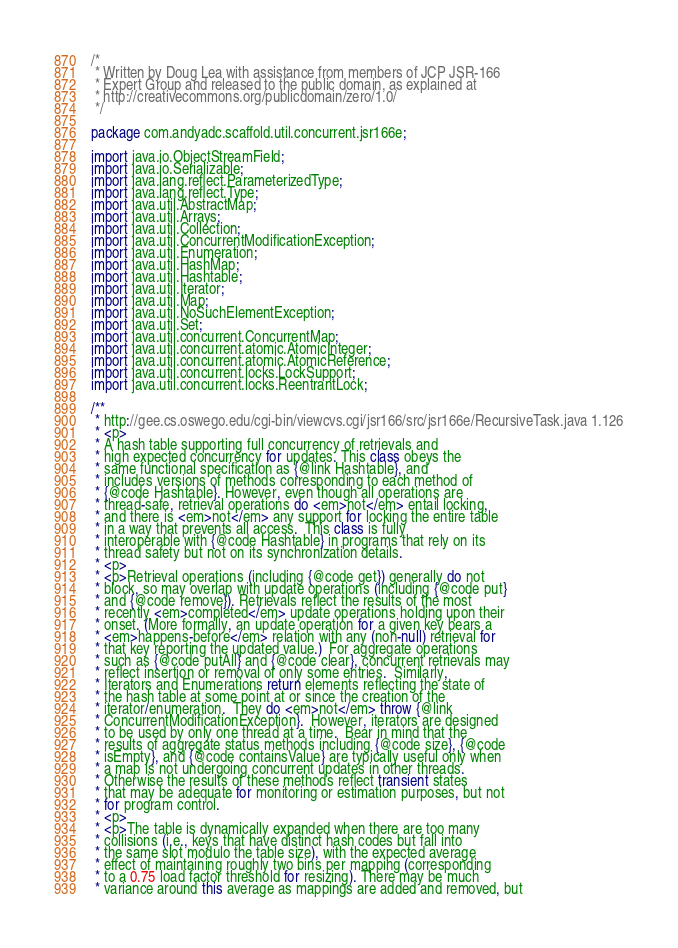Convert code to text. <code><loc_0><loc_0><loc_500><loc_500><_Java_>/*
 * Written by Doug Lea with assistance from members of JCP JSR-166
 * Expert Group and released to the public domain, as explained at
 * http://creativecommons.org/publicdomain/zero/1.0/
 */

package com.andyadc.scaffold.util.concurrent.jsr166e;

import java.io.ObjectStreamField;
import java.io.Serializable;
import java.lang.reflect.ParameterizedType;
import java.lang.reflect.Type;
import java.util.AbstractMap;
import java.util.Arrays;
import java.util.Collection;
import java.util.ConcurrentModificationException;
import java.util.Enumeration;
import java.util.HashMap;
import java.util.Hashtable;
import java.util.Iterator;
import java.util.Map;
import java.util.NoSuchElementException;
import java.util.Set;
import java.util.concurrent.ConcurrentMap;
import java.util.concurrent.atomic.AtomicInteger;
import java.util.concurrent.atomic.AtomicReference;
import java.util.concurrent.locks.LockSupport;
import java.util.concurrent.locks.ReentrantLock;

/**
 * http://gee.cs.oswego.edu/cgi-bin/viewcvs.cgi/jsr166/src/jsr166e/RecursiveTask.java 1.126
 * <p>
 * A hash table supporting full concurrency of retrievals and
 * high expected concurrency for updates. This class obeys the
 * same functional specification as {@link Hashtable}, and
 * includes versions of methods corresponding to each method of
 * {@code Hashtable}. However, even though all operations are
 * thread-safe, retrieval operations do <em>not</em> entail locking,
 * and there is <em>not</em> any support for locking the entire table
 * in a way that prevents all access.  This class is fully
 * interoperable with {@code Hashtable} in programs that rely on its
 * thread safety but not on its synchronization details.
 * <p>
 * <p>Retrieval operations (including {@code get}) generally do not
 * block, so may overlap with update operations (including {@code put}
 * and {@code remove}). Retrievals reflect the results of the most
 * recently <em>completed</em> update operations holding upon their
 * onset. (More formally, an update operation for a given key bears a
 * <em>happens-before</em> relation with any (non-null) retrieval for
 * that key reporting the updated value.)  For aggregate operations
 * such as {@code putAll} and {@code clear}, concurrent retrievals may
 * reflect insertion or removal of only some entries.  Similarly,
 * Iterators and Enumerations return elements reflecting the state of
 * the hash table at some point at or since the creation of the
 * iterator/enumeration.  They do <em>not</em> throw {@link
 * ConcurrentModificationException}.  However, iterators are designed
 * to be used by only one thread at a time.  Bear in mind that the
 * results of aggregate status methods including {@code size}, {@code
 * isEmpty}, and {@code containsValue} are typically useful only when
 * a map is not undergoing concurrent updates in other threads.
 * Otherwise the results of these methods reflect transient states
 * that may be adequate for monitoring or estimation purposes, but not
 * for program control.
 * <p>
 * <p>The table is dynamically expanded when there are too many
 * collisions (i.e., keys that have distinct hash codes but fall into
 * the same slot modulo the table size), with the expected average
 * effect of maintaining roughly two bins per mapping (corresponding
 * to a 0.75 load factor threshold for resizing). There may be much
 * variance around this average as mappings are added and removed, but</code> 